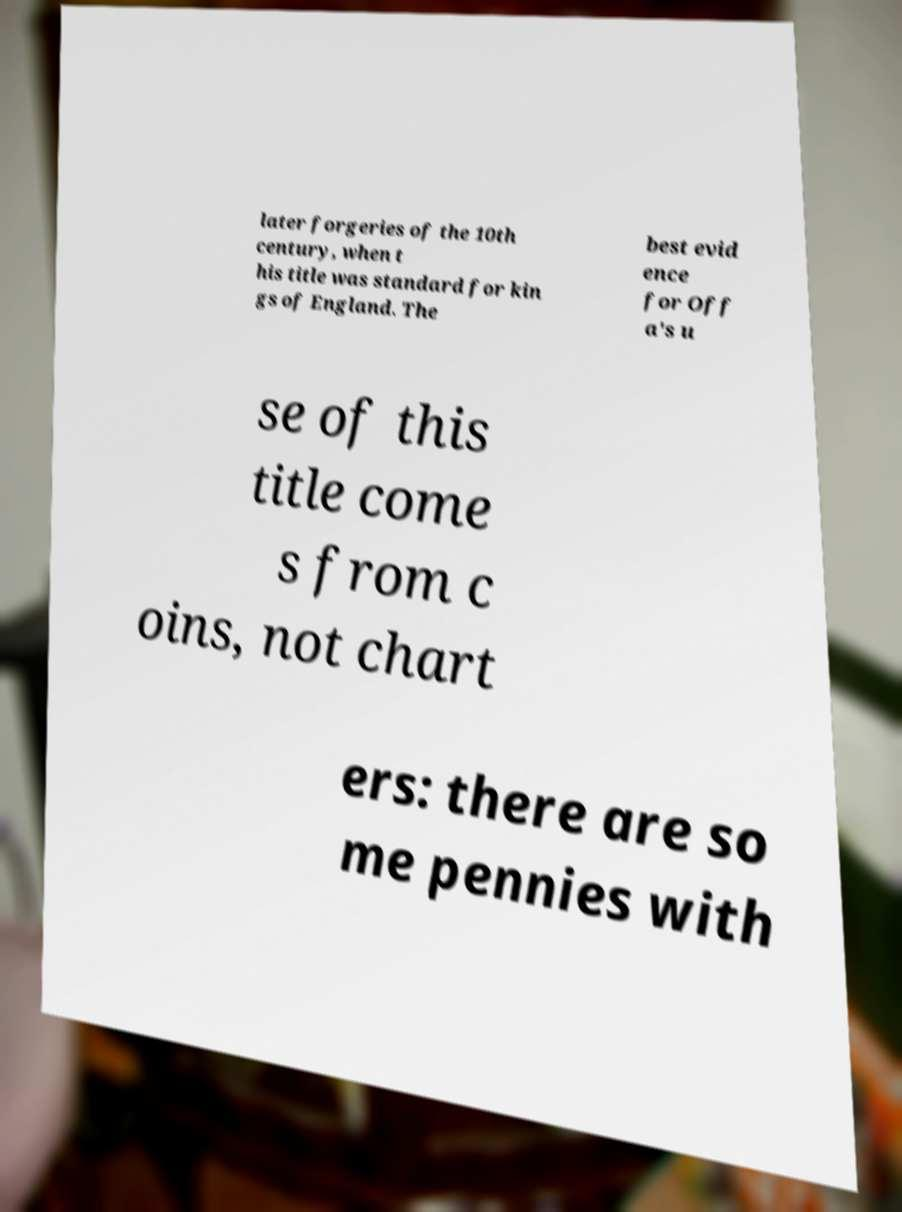What messages or text are displayed in this image? I need them in a readable, typed format. later forgeries of the 10th century, when t his title was standard for kin gs of England. The best evid ence for Off a's u se of this title come s from c oins, not chart ers: there are so me pennies with 